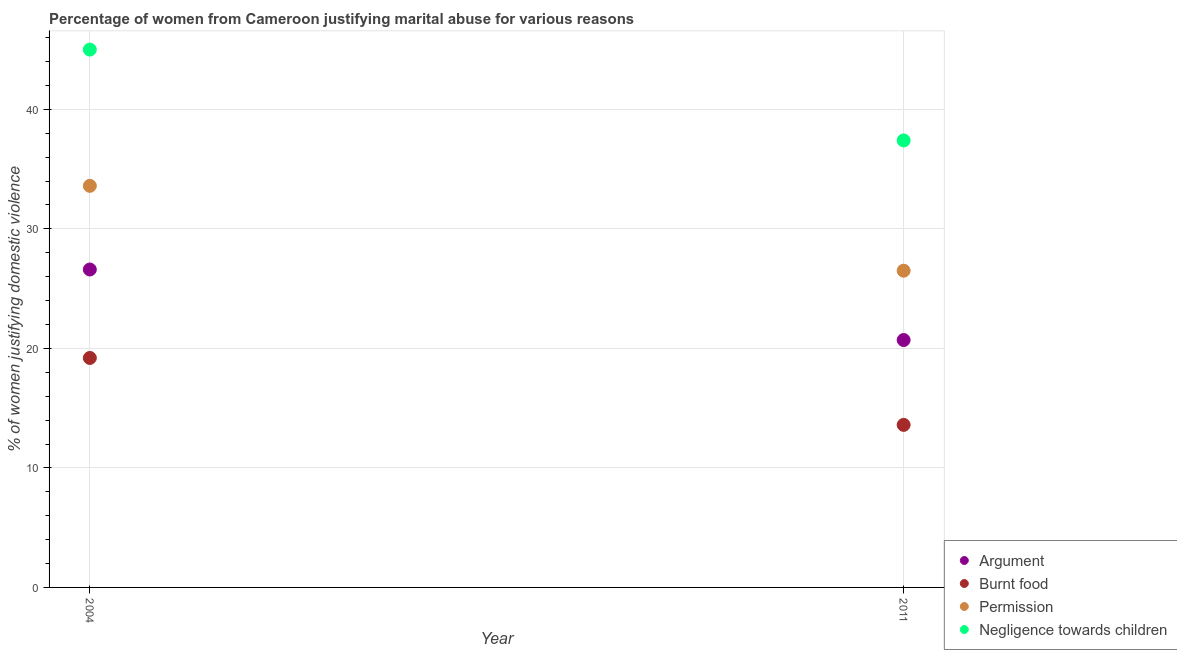How many different coloured dotlines are there?
Keep it short and to the point. 4. Across all years, what is the minimum percentage of women justifying abuse in the case of an argument?
Your response must be concise. 20.7. In which year was the percentage of women justifying abuse for going without permission minimum?
Give a very brief answer. 2011. What is the total percentage of women justifying abuse in the case of an argument in the graph?
Offer a very short reply. 47.3. What is the difference between the percentage of women justifying abuse for going without permission in 2004 and that in 2011?
Your answer should be compact. 7.1. What is the difference between the percentage of women justifying abuse for showing negligence towards children in 2011 and the percentage of women justifying abuse for going without permission in 2004?
Make the answer very short. 3.8. What is the average percentage of women justifying abuse for showing negligence towards children per year?
Keep it short and to the point. 41.2. In the year 2004, what is the difference between the percentage of women justifying abuse for going without permission and percentage of women justifying abuse for burning food?
Ensure brevity in your answer.  14.4. What is the ratio of the percentage of women justifying abuse in the case of an argument in 2004 to that in 2011?
Provide a short and direct response. 1.29. Is the percentage of women justifying abuse in the case of an argument in 2004 less than that in 2011?
Provide a succinct answer. No. Is it the case that in every year, the sum of the percentage of women justifying abuse in the case of an argument and percentage of women justifying abuse for burning food is greater than the percentage of women justifying abuse for going without permission?
Provide a short and direct response. Yes. Does the percentage of women justifying abuse for burning food monotonically increase over the years?
Offer a terse response. No. Is the percentage of women justifying abuse for showing negligence towards children strictly greater than the percentage of women justifying abuse in the case of an argument over the years?
Provide a short and direct response. Yes. How many dotlines are there?
Give a very brief answer. 4. What is the difference between two consecutive major ticks on the Y-axis?
Give a very brief answer. 10. Are the values on the major ticks of Y-axis written in scientific E-notation?
Offer a very short reply. No. Does the graph contain any zero values?
Offer a terse response. No. How are the legend labels stacked?
Ensure brevity in your answer.  Vertical. What is the title of the graph?
Your answer should be very brief. Percentage of women from Cameroon justifying marital abuse for various reasons. What is the label or title of the X-axis?
Give a very brief answer. Year. What is the label or title of the Y-axis?
Your response must be concise. % of women justifying domestic violence. What is the % of women justifying domestic violence in Argument in 2004?
Your response must be concise. 26.6. What is the % of women justifying domestic violence of Burnt food in 2004?
Provide a succinct answer. 19.2. What is the % of women justifying domestic violence of Permission in 2004?
Offer a very short reply. 33.6. What is the % of women justifying domestic violence in Negligence towards children in 2004?
Your response must be concise. 45. What is the % of women justifying domestic violence in Argument in 2011?
Your response must be concise. 20.7. What is the % of women justifying domestic violence of Burnt food in 2011?
Offer a terse response. 13.6. What is the % of women justifying domestic violence of Negligence towards children in 2011?
Provide a short and direct response. 37.4. Across all years, what is the maximum % of women justifying domestic violence of Argument?
Your response must be concise. 26.6. Across all years, what is the maximum % of women justifying domestic violence of Burnt food?
Ensure brevity in your answer.  19.2. Across all years, what is the maximum % of women justifying domestic violence of Permission?
Make the answer very short. 33.6. Across all years, what is the minimum % of women justifying domestic violence of Argument?
Your answer should be very brief. 20.7. Across all years, what is the minimum % of women justifying domestic violence in Burnt food?
Your answer should be compact. 13.6. Across all years, what is the minimum % of women justifying domestic violence of Negligence towards children?
Offer a terse response. 37.4. What is the total % of women justifying domestic violence of Argument in the graph?
Your response must be concise. 47.3. What is the total % of women justifying domestic violence in Burnt food in the graph?
Ensure brevity in your answer.  32.8. What is the total % of women justifying domestic violence in Permission in the graph?
Your answer should be very brief. 60.1. What is the total % of women justifying domestic violence of Negligence towards children in the graph?
Keep it short and to the point. 82.4. What is the difference between the % of women justifying domestic violence of Argument in 2004 and that in 2011?
Offer a very short reply. 5.9. What is the difference between the % of women justifying domestic violence in Argument in 2004 and the % of women justifying domestic violence in Burnt food in 2011?
Keep it short and to the point. 13. What is the difference between the % of women justifying domestic violence in Argument in 2004 and the % of women justifying domestic violence in Negligence towards children in 2011?
Provide a succinct answer. -10.8. What is the difference between the % of women justifying domestic violence of Burnt food in 2004 and the % of women justifying domestic violence of Permission in 2011?
Your response must be concise. -7.3. What is the difference between the % of women justifying domestic violence of Burnt food in 2004 and the % of women justifying domestic violence of Negligence towards children in 2011?
Give a very brief answer. -18.2. What is the average % of women justifying domestic violence in Argument per year?
Your answer should be compact. 23.65. What is the average % of women justifying domestic violence in Burnt food per year?
Give a very brief answer. 16.4. What is the average % of women justifying domestic violence in Permission per year?
Keep it short and to the point. 30.05. What is the average % of women justifying domestic violence in Negligence towards children per year?
Provide a succinct answer. 41.2. In the year 2004, what is the difference between the % of women justifying domestic violence in Argument and % of women justifying domestic violence in Permission?
Your response must be concise. -7. In the year 2004, what is the difference between the % of women justifying domestic violence in Argument and % of women justifying domestic violence in Negligence towards children?
Provide a short and direct response. -18.4. In the year 2004, what is the difference between the % of women justifying domestic violence of Burnt food and % of women justifying domestic violence of Permission?
Your response must be concise. -14.4. In the year 2004, what is the difference between the % of women justifying domestic violence of Burnt food and % of women justifying domestic violence of Negligence towards children?
Your answer should be compact. -25.8. In the year 2011, what is the difference between the % of women justifying domestic violence in Argument and % of women justifying domestic violence in Permission?
Keep it short and to the point. -5.8. In the year 2011, what is the difference between the % of women justifying domestic violence of Argument and % of women justifying domestic violence of Negligence towards children?
Your answer should be very brief. -16.7. In the year 2011, what is the difference between the % of women justifying domestic violence of Burnt food and % of women justifying domestic violence of Negligence towards children?
Your answer should be compact. -23.8. What is the ratio of the % of women justifying domestic violence in Argument in 2004 to that in 2011?
Provide a succinct answer. 1.28. What is the ratio of the % of women justifying domestic violence in Burnt food in 2004 to that in 2011?
Your response must be concise. 1.41. What is the ratio of the % of women justifying domestic violence of Permission in 2004 to that in 2011?
Give a very brief answer. 1.27. What is the ratio of the % of women justifying domestic violence of Negligence towards children in 2004 to that in 2011?
Ensure brevity in your answer.  1.2. What is the difference between the highest and the second highest % of women justifying domestic violence of Argument?
Keep it short and to the point. 5.9. What is the difference between the highest and the second highest % of women justifying domestic violence in Permission?
Make the answer very short. 7.1. What is the difference between the highest and the second highest % of women justifying domestic violence in Negligence towards children?
Make the answer very short. 7.6. 